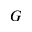Convert formula to latex. <formula><loc_0><loc_0><loc_500><loc_500>G</formula> 